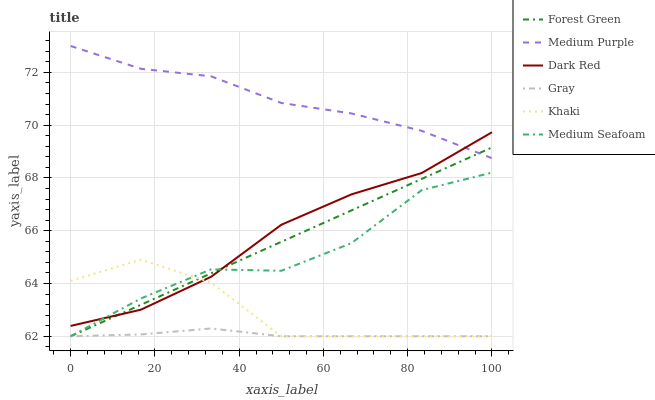Does Khaki have the minimum area under the curve?
Answer yes or no. No. Does Khaki have the maximum area under the curve?
Answer yes or no. No. Is Khaki the smoothest?
Answer yes or no. No. Is Khaki the roughest?
Answer yes or no. No. Does Dark Red have the lowest value?
Answer yes or no. No. Does Khaki have the highest value?
Answer yes or no. No. Is Medium Seafoam less than Medium Purple?
Answer yes or no. Yes. Is Medium Purple greater than Medium Seafoam?
Answer yes or no. Yes. Does Medium Seafoam intersect Medium Purple?
Answer yes or no. No. 